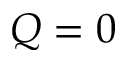<formula> <loc_0><loc_0><loc_500><loc_500>Q = 0</formula> 